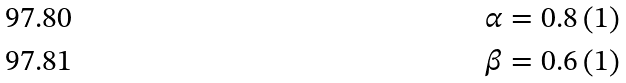Convert formula to latex. <formula><loc_0><loc_0><loc_500><loc_500>\alpha & = 0 . 8 \left ( 1 \right ) \\ \beta & = 0 . 6 \left ( 1 \right )</formula> 